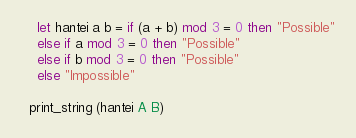<code> <loc_0><loc_0><loc_500><loc_500><_OCaml_>    let hantei a b = if (a + b) mod 3 = 0 then "Possible"
    else if a mod 3 = 0 then "Possible"
    else if b mod 3 = 0 then "Possible"
    else "Impossible"
     
  print_string (hantei A B)</code> 